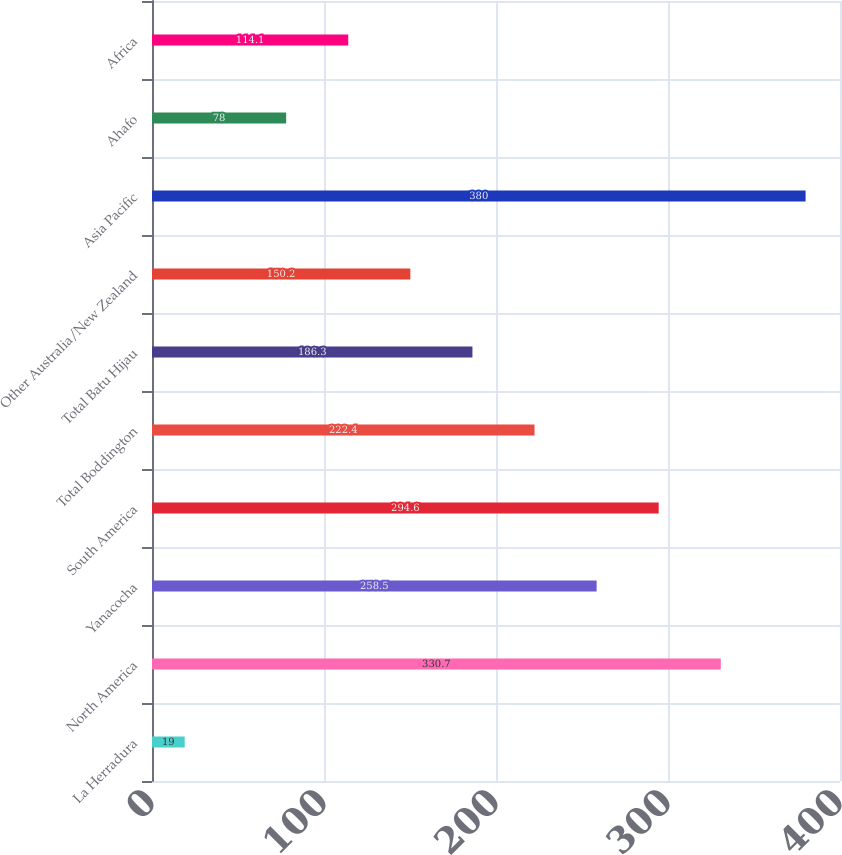Convert chart. <chart><loc_0><loc_0><loc_500><loc_500><bar_chart><fcel>La Herradura<fcel>North America<fcel>Yanacocha<fcel>South America<fcel>Total Boddington<fcel>Total Batu Hijau<fcel>Other Australia/New Zealand<fcel>Asia Pacific<fcel>Ahafo<fcel>Africa<nl><fcel>19<fcel>330.7<fcel>258.5<fcel>294.6<fcel>222.4<fcel>186.3<fcel>150.2<fcel>380<fcel>78<fcel>114.1<nl></chart> 